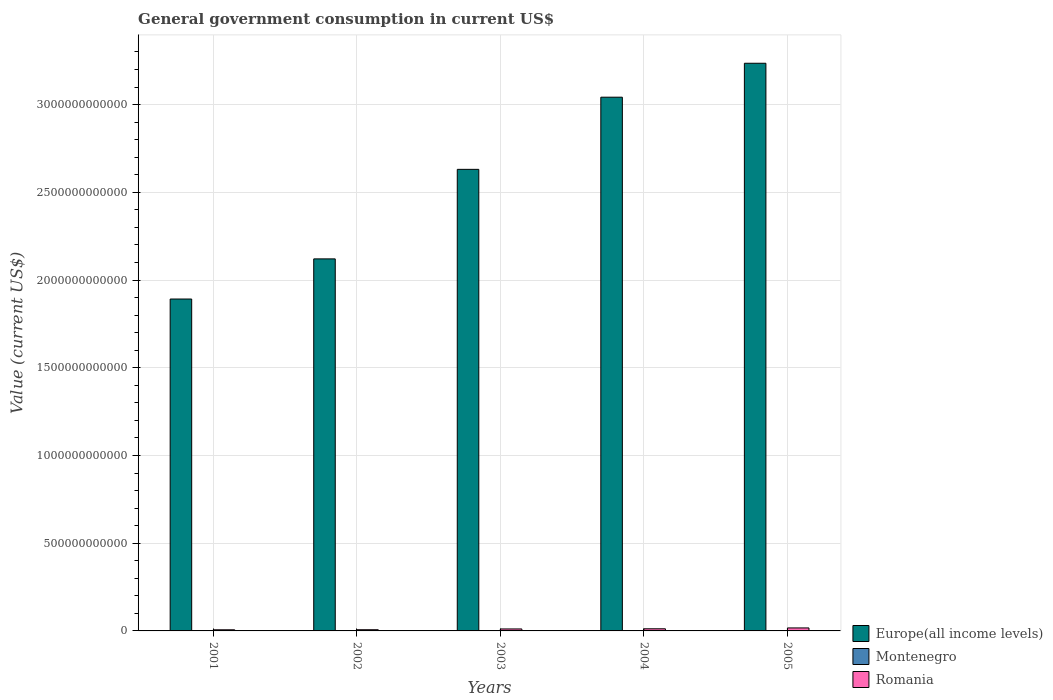How many different coloured bars are there?
Offer a very short reply. 3. How many groups of bars are there?
Give a very brief answer. 5. Are the number of bars on each tick of the X-axis equal?
Give a very brief answer. Yes. What is the government conusmption in Europe(all income levels) in 2005?
Your response must be concise. 3.24e+12. Across all years, what is the maximum government conusmption in Europe(all income levels)?
Your answer should be compact. 3.24e+12. Across all years, what is the minimum government conusmption in Europe(all income levels)?
Provide a short and direct response. 1.89e+12. In which year was the government conusmption in Romania minimum?
Give a very brief answer. 2001. What is the total government conusmption in Romania in the graph?
Your response must be concise. 5.38e+1. What is the difference between the government conusmption in Europe(all income levels) in 2002 and that in 2004?
Your answer should be very brief. -9.22e+11. What is the difference between the government conusmption in Montenegro in 2005 and the government conusmption in Europe(all income levels) in 2003?
Your answer should be compact. -2.63e+12. What is the average government conusmption in Romania per year?
Provide a succinct answer. 1.08e+1. In the year 2005, what is the difference between the government conusmption in Europe(all income levels) and government conusmption in Romania?
Offer a terse response. 3.22e+12. In how many years, is the government conusmption in Montenegro greater than 500000000000 US$?
Your answer should be compact. 0. What is the ratio of the government conusmption in Romania in 2002 to that in 2003?
Your response must be concise. 0.6. Is the government conusmption in Montenegro in 2001 less than that in 2003?
Give a very brief answer. Yes. Is the difference between the government conusmption in Europe(all income levels) in 2004 and 2005 greater than the difference between the government conusmption in Romania in 2004 and 2005?
Keep it short and to the point. No. What is the difference between the highest and the second highest government conusmption in Romania?
Offer a very short reply. 4.82e+09. What is the difference between the highest and the lowest government conusmption in Romania?
Keep it short and to the point. 1.05e+1. In how many years, is the government conusmption in Romania greater than the average government conusmption in Romania taken over all years?
Make the answer very short. 3. What does the 3rd bar from the left in 2001 represents?
Offer a terse response. Romania. What does the 3rd bar from the right in 2005 represents?
Your answer should be compact. Europe(all income levels). Is it the case that in every year, the sum of the government conusmption in Romania and government conusmption in Europe(all income levels) is greater than the government conusmption in Montenegro?
Ensure brevity in your answer.  Yes. How many bars are there?
Keep it short and to the point. 15. How many years are there in the graph?
Provide a short and direct response. 5. What is the difference between two consecutive major ticks on the Y-axis?
Keep it short and to the point. 5.00e+11. Does the graph contain any zero values?
Your answer should be very brief. No. Where does the legend appear in the graph?
Your response must be concise. Bottom right. How are the legend labels stacked?
Your response must be concise. Vertical. What is the title of the graph?
Keep it short and to the point. General government consumption in current US$. Does "Bulgaria" appear as one of the legend labels in the graph?
Keep it short and to the point. No. What is the label or title of the Y-axis?
Provide a short and direct response. Value (current US$). What is the Value (current US$) in Europe(all income levels) in 2001?
Offer a very short reply. 1.89e+12. What is the Value (current US$) in Montenegro in 2001?
Ensure brevity in your answer.  2.92e+08. What is the Value (current US$) in Romania in 2001?
Your answer should be compact. 6.49e+09. What is the Value (current US$) in Europe(all income levels) in 2002?
Provide a succinct answer. 2.12e+12. What is the Value (current US$) in Montenegro in 2002?
Provide a short and direct response. 3.19e+08. What is the Value (current US$) in Romania in 2002?
Give a very brief answer. 6.84e+09. What is the Value (current US$) in Europe(all income levels) in 2003?
Give a very brief answer. 2.63e+12. What is the Value (current US$) in Montenegro in 2003?
Keep it short and to the point. 4.57e+08. What is the Value (current US$) of Romania in 2003?
Your answer should be very brief. 1.13e+1. What is the Value (current US$) in Europe(all income levels) in 2004?
Your answer should be compact. 3.04e+12. What is the Value (current US$) of Montenegro in 2004?
Ensure brevity in your answer.  5.45e+08. What is the Value (current US$) of Romania in 2004?
Ensure brevity in your answer.  1.22e+1. What is the Value (current US$) of Europe(all income levels) in 2005?
Your answer should be compact. 3.24e+12. What is the Value (current US$) in Montenegro in 2005?
Keep it short and to the point. 6.76e+08. What is the Value (current US$) in Romania in 2005?
Provide a succinct answer. 1.70e+1. Across all years, what is the maximum Value (current US$) in Europe(all income levels)?
Your response must be concise. 3.24e+12. Across all years, what is the maximum Value (current US$) of Montenegro?
Keep it short and to the point. 6.76e+08. Across all years, what is the maximum Value (current US$) of Romania?
Your answer should be very brief. 1.70e+1. Across all years, what is the minimum Value (current US$) in Europe(all income levels)?
Offer a terse response. 1.89e+12. Across all years, what is the minimum Value (current US$) of Montenegro?
Offer a terse response. 2.92e+08. Across all years, what is the minimum Value (current US$) of Romania?
Ensure brevity in your answer.  6.49e+09. What is the total Value (current US$) in Europe(all income levels) in the graph?
Offer a terse response. 1.29e+13. What is the total Value (current US$) of Montenegro in the graph?
Make the answer very short. 2.29e+09. What is the total Value (current US$) of Romania in the graph?
Provide a succinct answer. 5.38e+1. What is the difference between the Value (current US$) of Europe(all income levels) in 2001 and that in 2002?
Your answer should be compact. -2.29e+11. What is the difference between the Value (current US$) of Montenegro in 2001 and that in 2002?
Offer a terse response. -2.74e+07. What is the difference between the Value (current US$) of Romania in 2001 and that in 2002?
Provide a succinct answer. -3.51e+08. What is the difference between the Value (current US$) in Europe(all income levels) in 2001 and that in 2003?
Provide a succinct answer. -7.39e+11. What is the difference between the Value (current US$) of Montenegro in 2001 and that in 2003?
Your answer should be compact. -1.65e+08. What is the difference between the Value (current US$) in Romania in 2001 and that in 2003?
Provide a succinct answer. -4.82e+09. What is the difference between the Value (current US$) in Europe(all income levels) in 2001 and that in 2004?
Provide a succinct answer. -1.15e+12. What is the difference between the Value (current US$) in Montenegro in 2001 and that in 2004?
Offer a very short reply. -2.53e+08. What is the difference between the Value (current US$) of Romania in 2001 and that in 2004?
Your answer should be very brief. -5.70e+09. What is the difference between the Value (current US$) in Europe(all income levels) in 2001 and that in 2005?
Your response must be concise. -1.34e+12. What is the difference between the Value (current US$) of Montenegro in 2001 and that in 2005?
Make the answer very short. -3.84e+08. What is the difference between the Value (current US$) in Romania in 2001 and that in 2005?
Make the answer very short. -1.05e+1. What is the difference between the Value (current US$) in Europe(all income levels) in 2002 and that in 2003?
Make the answer very short. -5.10e+11. What is the difference between the Value (current US$) of Montenegro in 2002 and that in 2003?
Provide a short and direct response. -1.38e+08. What is the difference between the Value (current US$) of Romania in 2002 and that in 2003?
Keep it short and to the point. -4.47e+09. What is the difference between the Value (current US$) of Europe(all income levels) in 2002 and that in 2004?
Offer a very short reply. -9.22e+11. What is the difference between the Value (current US$) of Montenegro in 2002 and that in 2004?
Offer a terse response. -2.26e+08. What is the difference between the Value (current US$) in Romania in 2002 and that in 2004?
Give a very brief answer. -5.35e+09. What is the difference between the Value (current US$) of Europe(all income levels) in 2002 and that in 2005?
Offer a terse response. -1.12e+12. What is the difference between the Value (current US$) in Montenegro in 2002 and that in 2005?
Offer a very short reply. -3.56e+08. What is the difference between the Value (current US$) of Romania in 2002 and that in 2005?
Give a very brief answer. -1.02e+1. What is the difference between the Value (current US$) in Europe(all income levels) in 2003 and that in 2004?
Ensure brevity in your answer.  -4.11e+11. What is the difference between the Value (current US$) of Montenegro in 2003 and that in 2004?
Your response must be concise. -8.83e+07. What is the difference between the Value (current US$) in Romania in 2003 and that in 2004?
Keep it short and to the point. -8.86e+08. What is the difference between the Value (current US$) in Europe(all income levels) in 2003 and that in 2005?
Keep it short and to the point. -6.05e+11. What is the difference between the Value (current US$) of Montenegro in 2003 and that in 2005?
Offer a very short reply. -2.19e+08. What is the difference between the Value (current US$) of Romania in 2003 and that in 2005?
Make the answer very short. -5.71e+09. What is the difference between the Value (current US$) of Europe(all income levels) in 2004 and that in 2005?
Make the answer very short. -1.93e+11. What is the difference between the Value (current US$) in Montenegro in 2004 and that in 2005?
Provide a succinct answer. -1.30e+08. What is the difference between the Value (current US$) in Romania in 2004 and that in 2005?
Your response must be concise. -4.82e+09. What is the difference between the Value (current US$) in Europe(all income levels) in 2001 and the Value (current US$) in Montenegro in 2002?
Your answer should be compact. 1.89e+12. What is the difference between the Value (current US$) of Europe(all income levels) in 2001 and the Value (current US$) of Romania in 2002?
Provide a succinct answer. 1.88e+12. What is the difference between the Value (current US$) of Montenegro in 2001 and the Value (current US$) of Romania in 2002?
Your answer should be compact. -6.55e+09. What is the difference between the Value (current US$) of Europe(all income levels) in 2001 and the Value (current US$) of Montenegro in 2003?
Provide a short and direct response. 1.89e+12. What is the difference between the Value (current US$) in Europe(all income levels) in 2001 and the Value (current US$) in Romania in 2003?
Your answer should be very brief. 1.88e+12. What is the difference between the Value (current US$) in Montenegro in 2001 and the Value (current US$) in Romania in 2003?
Offer a terse response. -1.10e+1. What is the difference between the Value (current US$) in Europe(all income levels) in 2001 and the Value (current US$) in Montenegro in 2004?
Make the answer very short. 1.89e+12. What is the difference between the Value (current US$) in Europe(all income levels) in 2001 and the Value (current US$) in Romania in 2004?
Give a very brief answer. 1.88e+12. What is the difference between the Value (current US$) of Montenegro in 2001 and the Value (current US$) of Romania in 2004?
Offer a very short reply. -1.19e+1. What is the difference between the Value (current US$) in Europe(all income levels) in 2001 and the Value (current US$) in Montenegro in 2005?
Your answer should be compact. 1.89e+12. What is the difference between the Value (current US$) in Europe(all income levels) in 2001 and the Value (current US$) in Romania in 2005?
Provide a succinct answer. 1.87e+12. What is the difference between the Value (current US$) in Montenegro in 2001 and the Value (current US$) in Romania in 2005?
Make the answer very short. -1.67e+1. What is the difference between the Value (current US$) of Europe(all income levels) in 2002 and the Value (current US$) of Montenegro in 2003?
Your answer should be very brief. 2.12e+12. What is the difference between the Value (current US$) in Europe(all income levels) in 2002 and the Value (current US$) in Romania in 2003?
Keep it short and to the point. 2.11e+12. What is the difference between the Value (current US$) in Montenegro in 2002 and the Value (current US$) in Romania in 2003?
Offer a terse response. -1.10e+1. What is the difference between the Value (current US$) in Europe(all income levels) in 2002 and the Value (current US$) in Montenegro in 2004?
Make the answer very short. 2.12e+12. What is the difference between the Value (current US$) in Europe(all income levels) in 2002 and the Value (current US$) in Romania in 2004?
Offer a very short reply. 2.11e+12. What is the difference between the Value (current US$) in Montenegro in 2002 and the Value (current US$) in Romania in 2004?
Provide a succinct answer. -1.19e+1. What is the difference between the Value (current US$) of Europe(all income levels) in 2002 and the Value (current US$) of Montenegro in 2005?
Offer a very short reply. 2.12e+12. What is the difference between the Value (current US$) of Europe(all income levels) in 2002 and the Value (current US$) of Romania in 2005?
Keep it short and to the point. 2.10e+12. What is the difference between the Value (current US$) in Montenegro in 2002 and the Value (current US$) in Romania in 2005?
Ensure brevity in your answer.  -1.67e+1. What is the difference between the Value (current US$) of Europe(all income levels) in 2003 and the Value (current US$) of Montenegro in 2004?
Ensure brevity in your answer.  2.63e+12. What is the difference between the Value (current US$) in Europe(all income levels) in 2003 and the Value (current US$) in Romania in 2004?
Offer a terse response. 2.62e+12. What is the difference between the Value (current US$) in Montenegro in 2003 and the Value (current US$) in Romania in 2004?
Provide a short and direct response. -1.17e+1. What is the difference between the Value (current US$) in Europe(all income levels) in 2003 and the Value (current US$) in Montenegro in 2005?
Keep it short and to the point. 2.63e+12. What is the difference between the Value (current US$) of Europe(all income levels) in 2003 and the Value (current US$) of Romania in 2005?
Provide a short and direct response. 2.61e+12. What is the difference between the Value (current US$) of Montenegro in 2003 and the Value (current US$) of Romania in 2005?
Your answer should be very brief. -1.66e+1. What is the difference between the Value (current US$) of Europe(all income levels) in 2004 and the Value (current US$) of Montenegro in 2005?
Make the answer very short. 3.04e+12. What is the difference between the Value (current US$) in Europe(all income levels) in 2004 and the Value (current US$) in Romania in 2005?
Make the answer very short. 3.03e+12. What is the difference between the Value (current US$) in Montenegro in 2004 and the Value (current US$) in Romania in 2005?
Ensure brevity in your answer.  -1.65e+1. What is the average Value (current US$) of Europe(all income levels) per year?
Keep it short and to the point. 2.58e+12. What is the average Value (current US$) in Montenegro per year?
Provide a short and direct response. 4.58e+08. What is the average Value (current US$) in Romania per year?
Give a very brief answer. 1.08e+1. In the year 2001, what is the difference between the Value (current US$) in Europe(all income levels) and Value (current US$) in Montenegro?
Provide a succinct answer. 1.89e+12. In the year 2001, what is the difference between the Value (current US$) of Europe(all income levels) and Value (current US$) of Romania?
Ensure brevity in your answer.  1.89e+12. In the year 2001, what is the difference between the Value (current US$) of Montenegro and Value (current US$) of Romania?
Keep it short and to the point. -6.20e+09. In the year 2002, what is the difference between the Value (current US$) of Europe(all income levels) and Value (current US$) of Montenegro?
Offer a very short reply. 2.12e+12. In the year 2002, what is the difference between the Value (current US$) of Europe(all income levels) and Value (current US$) of Romania?
Provide a succinct answer. 2.11e+12. In the year 2002, what is the difference between the Value (current US$) of Montenegro and Value (current US$) of Romania?
Make the answer very short. -6.52e+09. In the year 2003, what is the difference between the Value (current US$) in Europe(all income levels) and Value (current US$) in Montenegro?
Provide a short and direct response. 2.63e+12. In the year 2003, what is the difference between the Value (current US$) of Europe(all income levels) and Value (current US$) of Romania?
Offer a terse response. 2.62e+12. In the year 2003, what is the difference between the Value (current US$) in Montenegro and Value (current US$) in Romania?
Ensure brevity in your answer.  -1.08e+1. In the year 2004, what is the difference between the Value (current US$) in Europe(all income levels) and Value (current US$) in Montenegro?
Ensure brevity in your answer.  3.04e+12. In the year 2004, what is the difference between the Value (current US$) of Europe(all income levels) and Value (current US$) of Romania?
Make the answer very short. 3.03e+12. In the year 2004, what is the difference between the Value (current US$) in Montenegro and Value (current US$) in Romania?
Offer a very short reply. -1.16e+1. In the year 2005, what is the difference between the Value (current US$) in Europe(all income levels) and Value (current US$) in Montenegro?
Make the answer very short. 3.23e+12. In the year 2005, what is the difference between the Value (current US$) in Europe(all income levels) and Value (current US$) in Romania?
Offer a terse response. 3.22e+12. In the year 2005, what is the difference between the Value (current US$) in Montenegro and Value (current US$) in Romania?
Make the answer very short. -1.63e+1. What is the ratio of the Value (current US$) in Europe(all income levels) in 2001 to that in 2002?
Offer a very short reply. 0.89. What is the ratio of the Value (current US$) of Montenegro in 2001 to that in 2002?
Keep it short and to the point. 0.91. What is the ratio of the Value (current US$) of Romania in 2001 to that in 2002?
Offer a terse response. 0.95. What is the ratio of the Value (current US$) of Europe(all income levels) in 2001 to that in 2003?
Offer a terse response. 0.72. What is the ratio of the Value (current US$) of Montenegro in 2001 to that in 2003?
Ensure brevity in your answer.  0.64. What is the ratio of the Value (current US$) in Romania in 2001 to that in 2003?
Provide a succinct answer. 0.57. What is the ratio of the Value (current US$) in Europe(all income levels) in 2001 to that in 2004?
Your answer should be very brief. 0.62. What is the ratio of the Value (current US$) of Montenegro in 2001 to that in 2004?
Provide a short and direct response. 0.54. What is the ratio of the Value (current US$) in Romania in 2001 to that in 2004?
Offer a terse response. 0.53. What is the ratio of the Value (current US$) in Europe(all income levels) in 2001 to that in 2005?
Your answer should be compact. 0.58. What is the ratio of the Value (current US$) of Montenegro in 2001 to that in 2005?
Offer a very short reply. 0.43. What is the ratio of the Value (current US$) in Romania in 2001 to that in 2005?
Provide a succinct answer. 0.38. What is the ratio of the Value (current US$) in Europe(all income levels) in 2002 to that in 2003?
Your answer should be very brief. 0.81. What is the ratio of the Value (current US$) of Montenegro in 2002 to that in 2003?
Provide a short and direct response. 0.7. What is the ratio of the Value (current US$) in Romania in 2002 to that in 2003?
Ensure brevity in your answer.  0.6. What is the ratio of the Value (current US$) of Europe(all income levels) in 2002 to that in 2004?
Offer a terse response. 0.7. What is the ratio of the Value (current US$) of Montenegro in 2002 to that in 2004?
Keep it short and to the point. 0.59. What is the ratio of the Value (current US$) of Romania in 2002 to that in 2004?
Keep it short and to the point. 0.56. What is the ratio of the Value (current US$) in Europe(all income levels) in 2002 to that in 2005?
Your answer should be very brief. 0.66. What is the ratio of the Value (current US$) in Montenegro in 2002 to that in 2005?
Your answer should be compact. 0.47. What is the ratio of the Value (current US$) of Romania in 2002 to that in 2005?
Make the answer very short. 0.4. What is the ratio of the Value (current US$) of Europe(all income levels) in 2003 to that in 2004?
Give a very brief answer. 0.86. What is the ratio of the Value (current US$) in Montenegro in 2003 to that in 2004?
Provide a short and direct response. 0.84. What is the ratio of the Value (current US$) in Romania in 2003 to that in 2004?
Offer a very short reply. 0.93. What is the ratio of the Value (current US$) in Europe(all income levels) in 2003 to that in 2005?
Provide a short and direct response. 0.81. What is the ratio of the Value (current US$) of Montenegro in 2003 to that in 2005?
Give a very brief answer. 0.68. What is the ratio of the Value (current US$) of Romania in 2003 to that in 2005?
Your answer should be compact. 0.66. What is the ratio of the Value (current US$) in Europe(all income levels) in 2004 to that in 2005?
Your answer should be compact. 0.94. What is the ratio of the Value (current US$) of Montenegro in 2004 to that in 2005?
Ensure brevity in your answer.  0.81. What is the ratio of the Value (current US$) of Romania in 2004 to that in 2005?
Give a very brief answer. 0.72. What is the difference between the highest and the second highest Value (current US$) in Europe(all income levels)?
Provide a short and direct response. 1.93e+11. What is the difference between the highest and the second highest Value (current US$) of Montenegro?
Provide a succinct answer. 1.30e+08. What is the difference between the highest and the second highest Value (current US$) in Romania?
Your answer should be compact. 4.82e+09. What is the difference between the highest and the lowest Value (current US$) of Europe(all income levels)?
Ensure brevity in your answer.  1.34e+12. What is the difference between the highest and the lowest Value (current US$) of Montenegro?
Provide a succinct answer. 3.84e+08. What is the difference between the highest and the lowest Value (current US$) in Romania?
Your response must be concise. 1.05e+1. 